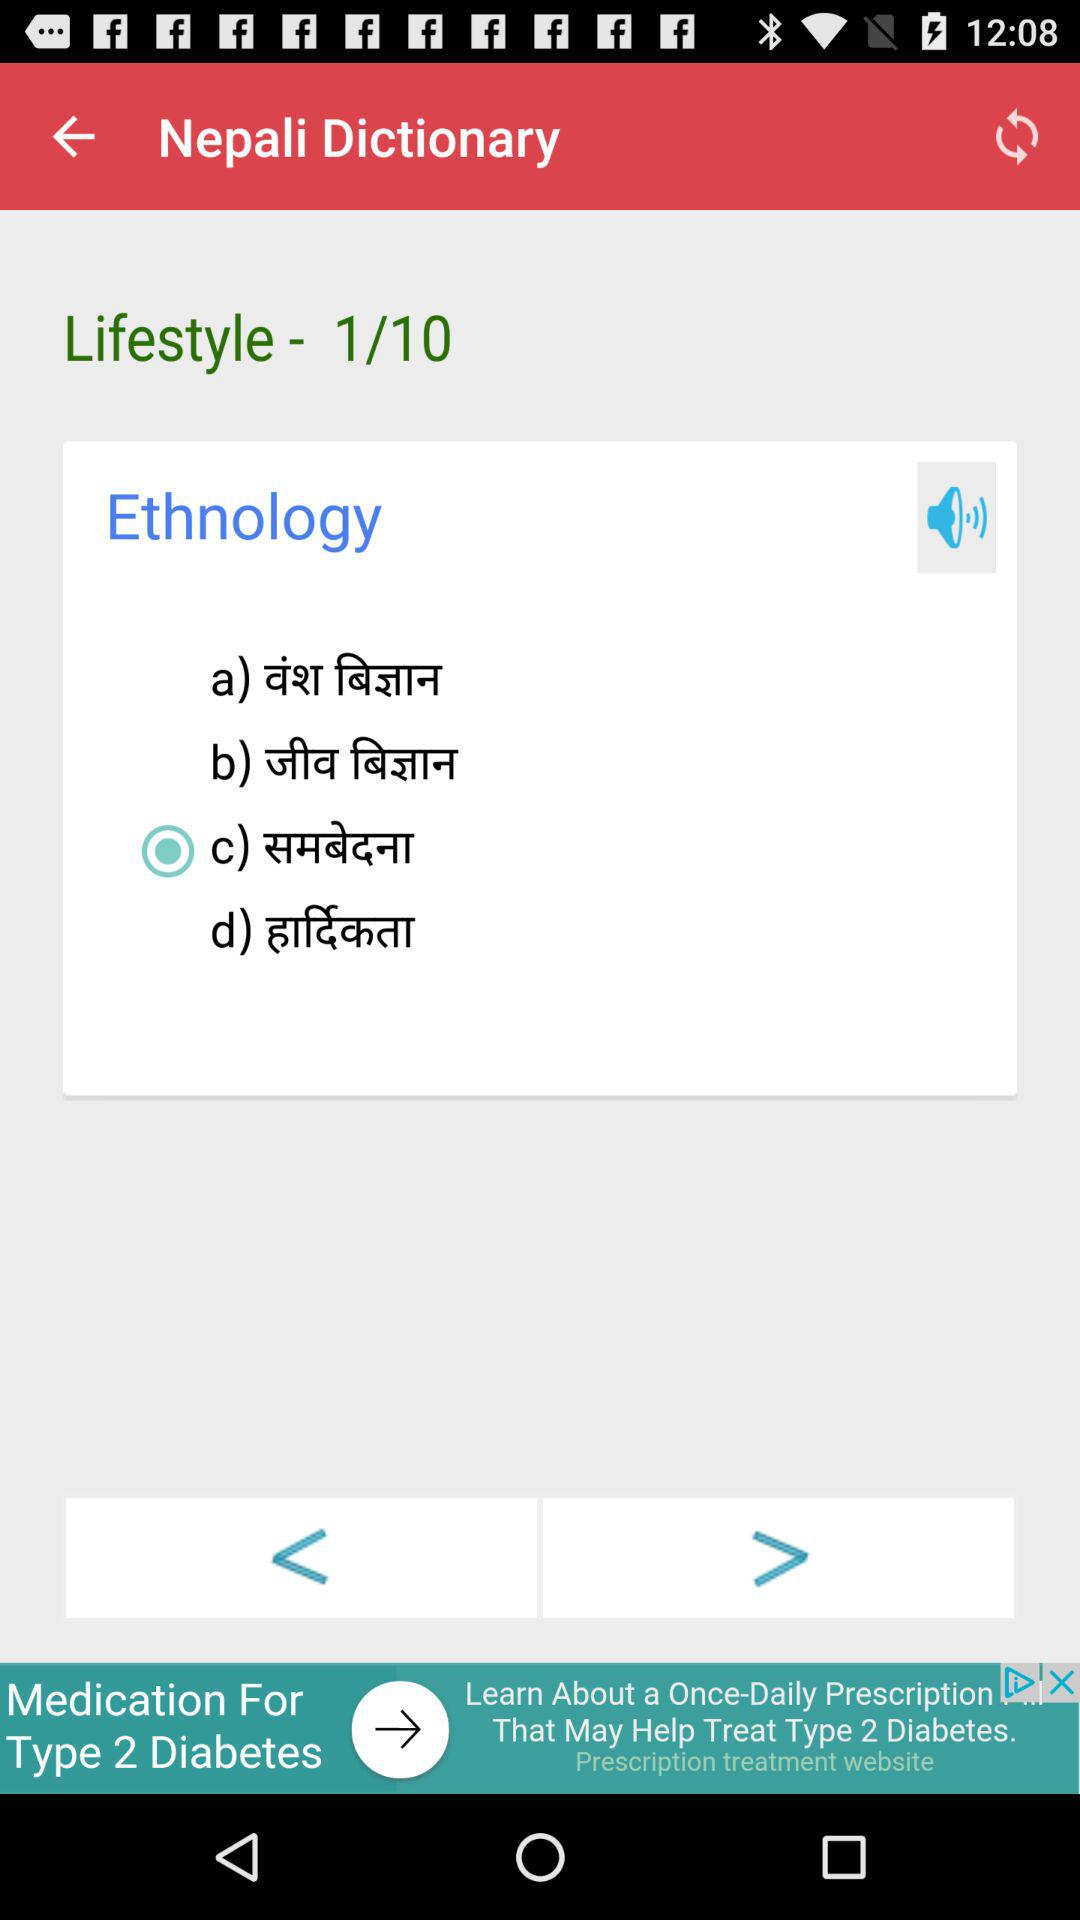At which question number are we? You are at the first question number. 